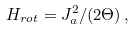<formula> <loc_0><loc_0><loc_500><loc_500>H _ { r o t } = J _ { a } ^ { 2 } / ( 2 \Theta ) \, ,</formula> 